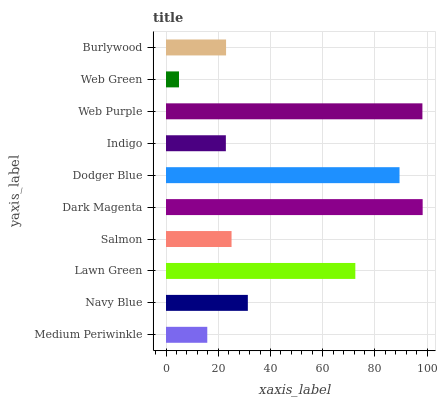Is Web Green the minimum?
Answer yes or no. Yes. Is Dark Magenta the maximum?
Answer yes or no. Yes. Is Navy Blue the minimum?
Answer yes or no. No. Is Navy Blue the maximum?
Answer yes or no. No. Is Navy Blue greater than Medium Periwinkle?
Answer yes or no. Yes. Is Medium Periwinkle less than Navy Blue?
Answer yes or no. Yes. Is Medium Periwinkle greater than Navy Blue?
Answer yes or no. No. Is Navy Blue less than Medium Periwinkle?
Answer yes or no. No. Is Navy Blue the high median?
Answer yes or no. Yes. Is Salmon the low median?
Answer yes or no. Yes. Is Web Green the high median?
Answer yes or no. No. Is Lawn Green the low median?
Answer yes or no. No. 